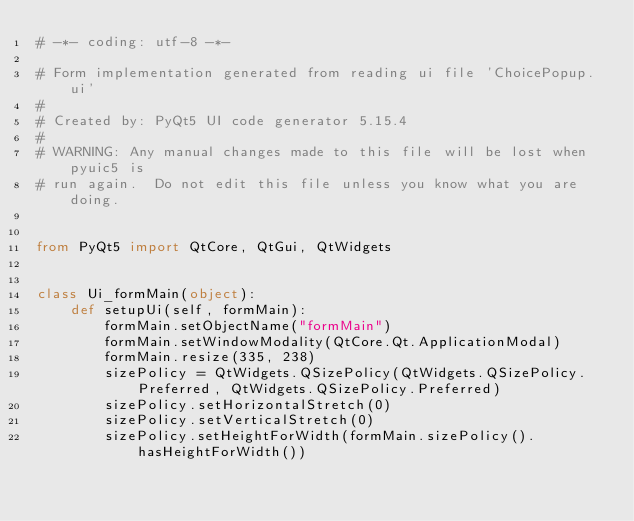Convert code to text. <code><loc_0><loc_0><loc_500><loc_500><_Python_># -*- coding: utf-8 -*-

# Form implementation generated from reading ui file 'ChoicePopup.ui'
#
# Created by: PyQt5 UI code generator 5.15.4
#
# WARNING: Any manual changes made to this file will be lost when pyuic5 is
# run again.  Do not edit this file unless you know what you are doing.


from PyQt5 import QtCore, QtGui, QtWidgets


class Ui_formMain(object):
    def setupUi(self, formMain):
        formMain.setObjectName("formMain")
        formMain.setWindowModality(QtCore.Qt.ApplicationModal)
        formMain.resize(335, 238)
        sizePolicy = QtWidgets.QSizePolicy(QtWidgets.QSizePolicy.Preferred, QtWidgets.QSizePolicy.Preferred)
        sizePolicy.setHorizontalStretch(0)
        sizePolicy.setVerticalStretch(0)
        sizePolicy.setHeightForWidth(formMain.sizePolicy().hasHeightForWidth())</code> 